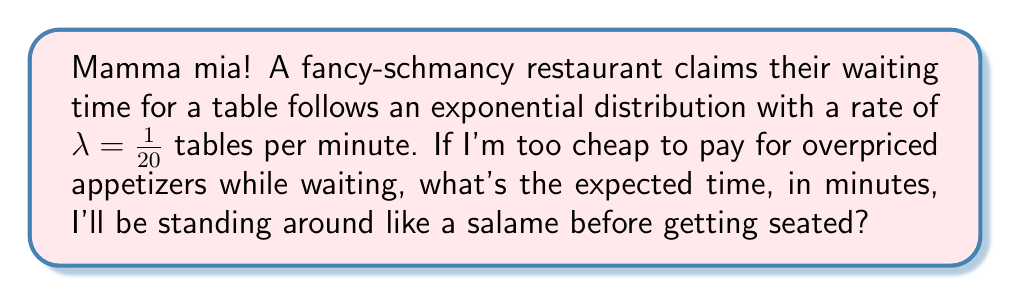Give your solution to this math problem. Let's break this down step-by-step:

1) For an exponential distribution, the expected value (mean) is given by:

   $$ E[X] = \frac{1}{\lambda} $$

   where $\lambda$ is the rate parameter.

2) We're given that $\lambda = \frac{1}{20}$ tables per minute.

3) Substituting this into our formula:

   $$ E[X] = \frac{1}{\frac{1}{20}} $$

4) To simplify this fraction, we can flip the denominator:

   $$ E[X] = 20 $$

5) Therefore, the expected waiting time is 20 minutes.

This means that on average, you'll be waiting 20 minutes for a table. Mamma mia, indeed! That's a long time to be standing around when you could be at home making your own delicious pasta!
Answer: 20 minutes 